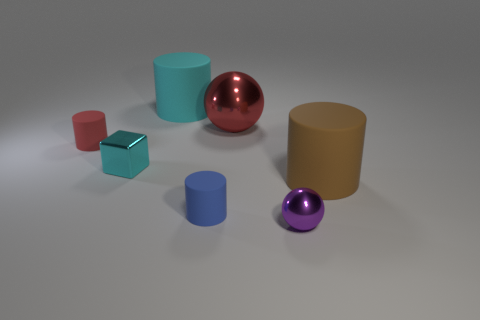Does the block have the same color as the tiny shiny ball?
Provide a succinct answer. No. What number of things are both behind the cube and to the left of the big cyan thing?
Provide a short and direct response. 1. What is the large brown cylinder made of?
Your answer should be compact. Rubber. Is there any other thing that is the same color as the metallic cube?
Your response must be concise. Yes. Does the small blue cylinder have the same material as the big brown cylinder?
Provide a succinct answer. Yes. There is a small rubber cylinder that is behind the large cylinder that is in front of the small red cylinder; what number of small objects are in front of it?
Your answer should be very brief. 3. What number of spheres are there?
Your answer should be very brief. 2. Is the number of big cyan cylinders behind the large red sphere less than the number of big red spheres that are behind the cyan cylinder?
Provide a short and direct response. No. Is the number of tiny purple metal spheres that are left of the red matte object less than the number of brown cylinders?
Provide a short and direct response. Yes. What material is the big cyan cylinder left of the shiny sphere behind the small shiny thing behind the small sphere?
Your answer should be very brief. Rubber. 